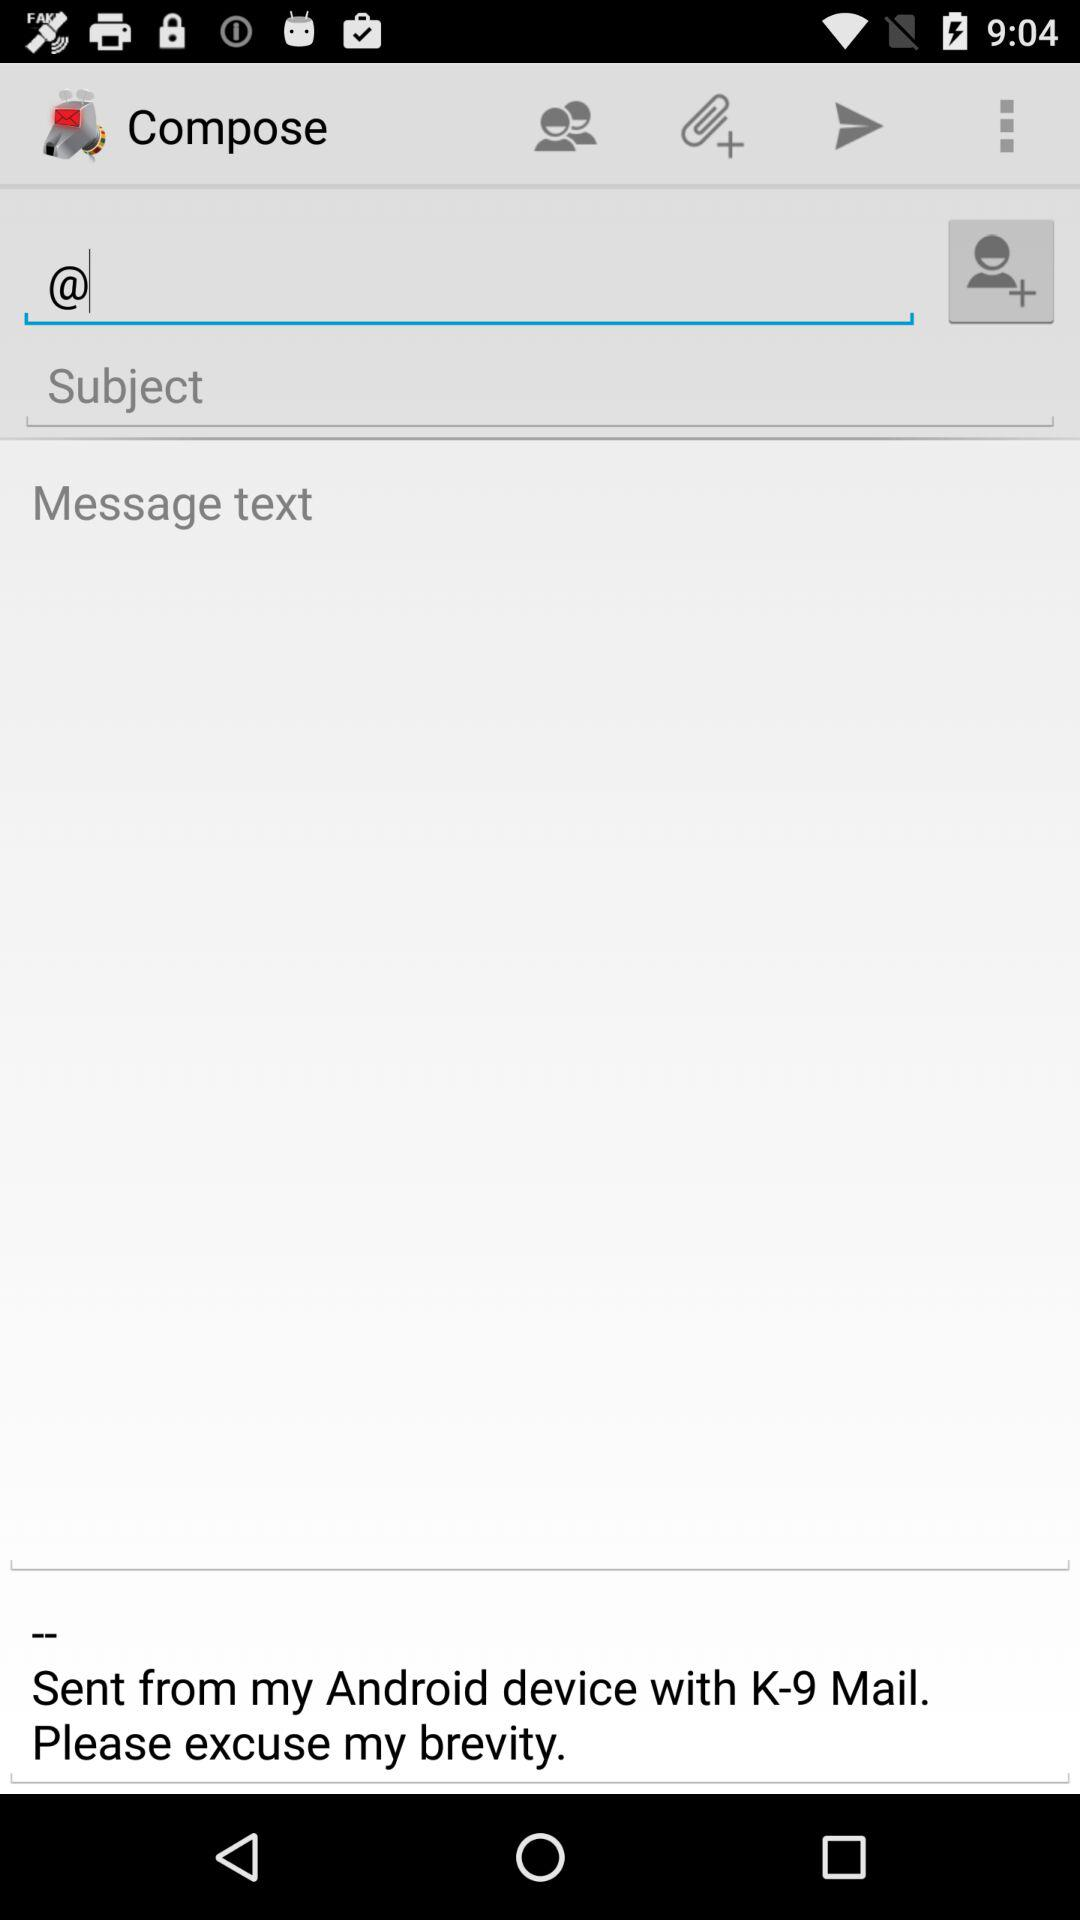From where is it sent? It is sent from "Android device". 